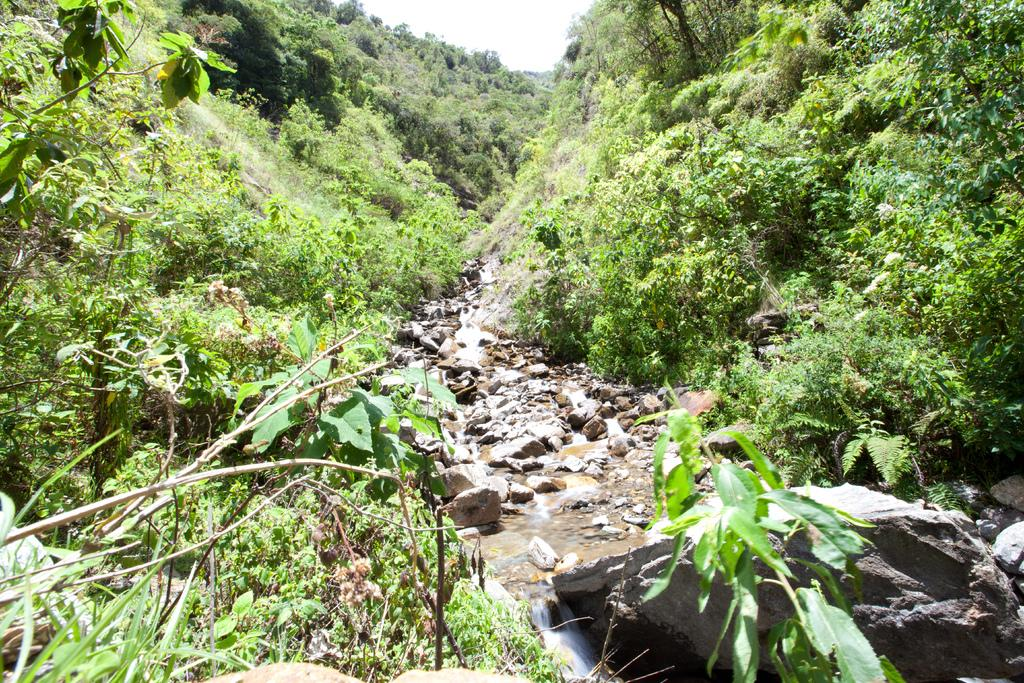What type of natural elements can be seen in the image? There are many trees, plants, water, and stones visible in the image. How many types of vegetation can be seen in the image? There are trees and plants visible in the image. What is visible in the sky in the image? The sky is visible in the image. How many rocks can be seen in the image? There are few rocks visible in the image. What type of mask is being worn by the tree in the image? There is no mask present in the image. How much sugar can be seen in the image? There is no sugar present in the image. 